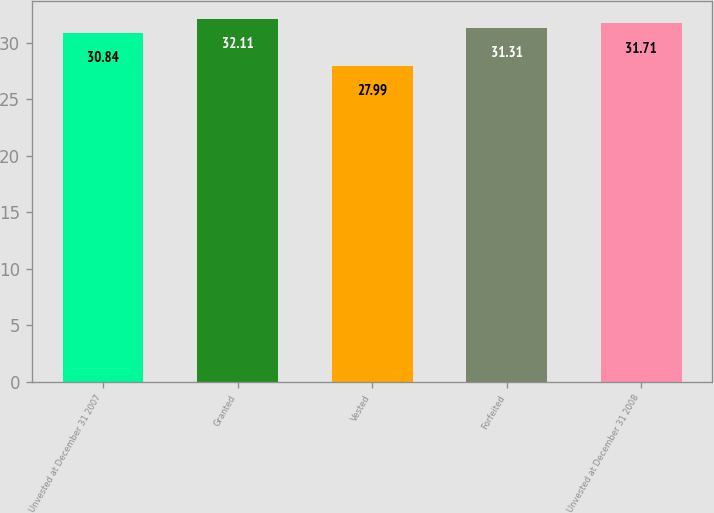Convert chart. <chart><loc_0><loc_0><loc_500><loc_500><bar_chart><fcel>Unvested at December 31 2007<fcel>Granted<fcel>Vested<fcel>Forfeited<fcel>Unvested at December 31 2008<nl><fcel>30.84<fcel>32.11<fcel>27.99<fcel>31.31<fcel>31.71<nl></chart> 